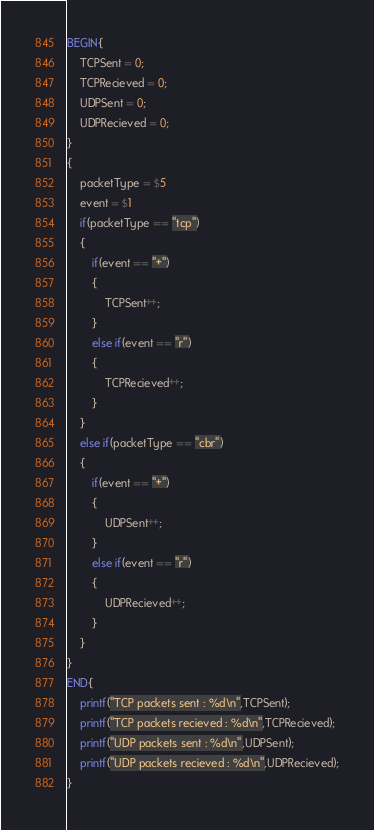Convert code to text. <code><loc_0><loc_0><loc_500><loc_500><_Awk_>BEGIN{
    TCPSent = 0;
    TCPRecieved = 0;
    UDPSent = 0;
    UDPRecieved = 0;
}
{
    packetType = $5
    event = $1
    if(packetType == "tcp")
    {
        if(event == "+")
        {
            TCPSent++;
        }
        else if(event == "r")
        {
            TCPRecieved++;
        }
    }
    else if(packetType == "cbr")
    {
        if(event == "+")
        {
            UDPSent++;
        }
        else if(event == "r")
        {
            UDPRecieved++;
        }
    }
}
END{
    printf("TCP packets sent : %d\n",TCPSent);
    printf("TCP packets recieved : %d\n",TCPRecieved);
    printf("UDP packets sent : %d\n",UDPSent);
    printf("UDP packets recieved : %d\n",UDPRecieved);
}</code> 